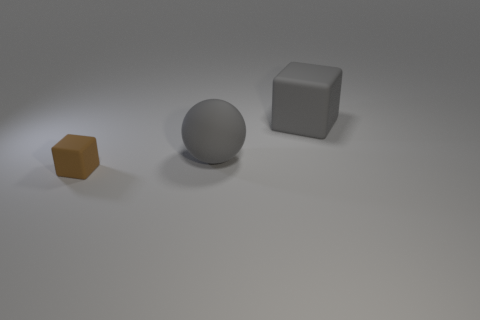There is a gray object in front of the cube behind the thing in front of the sphere; what is its material?
Ensure brevity in your answer.  Rubber. Are there any big rubber blocks of the same color as the tiny rubber cube?
Your answer should be very brief. No. Is the number of large gray matte spheres that are to the left of the tiny brown block less than the number of gray rubber spheres?
Keep it short and to the point. Yes. Do the rubber object that is behind the matte sphere and the tiny cube have the same size?
Your response must be concise. No. How many matte cubes are both in front of the gray matte ball and behind the brown thing?
Give a very brief answer. 0. There is a brown thing in front of the matte cube behind the small rubber block; how big is it?
Offer a terse response. Small. Is the number of brown things behind the small rubber object less than the number of balls to the right of the large gray cube?
Provide a succinct answer. No. There is a rubber cube that is behind the gray rubber ball; is its color the same as the rubber block in front of the sphere?
Offer a very short reply. No. There is a object that is in front of the large block and right of the small brown block; what is its material?
Offer a very short reply. Rubber. Are there any green metal spheres?
Ensure brevity in your answer.  No. 